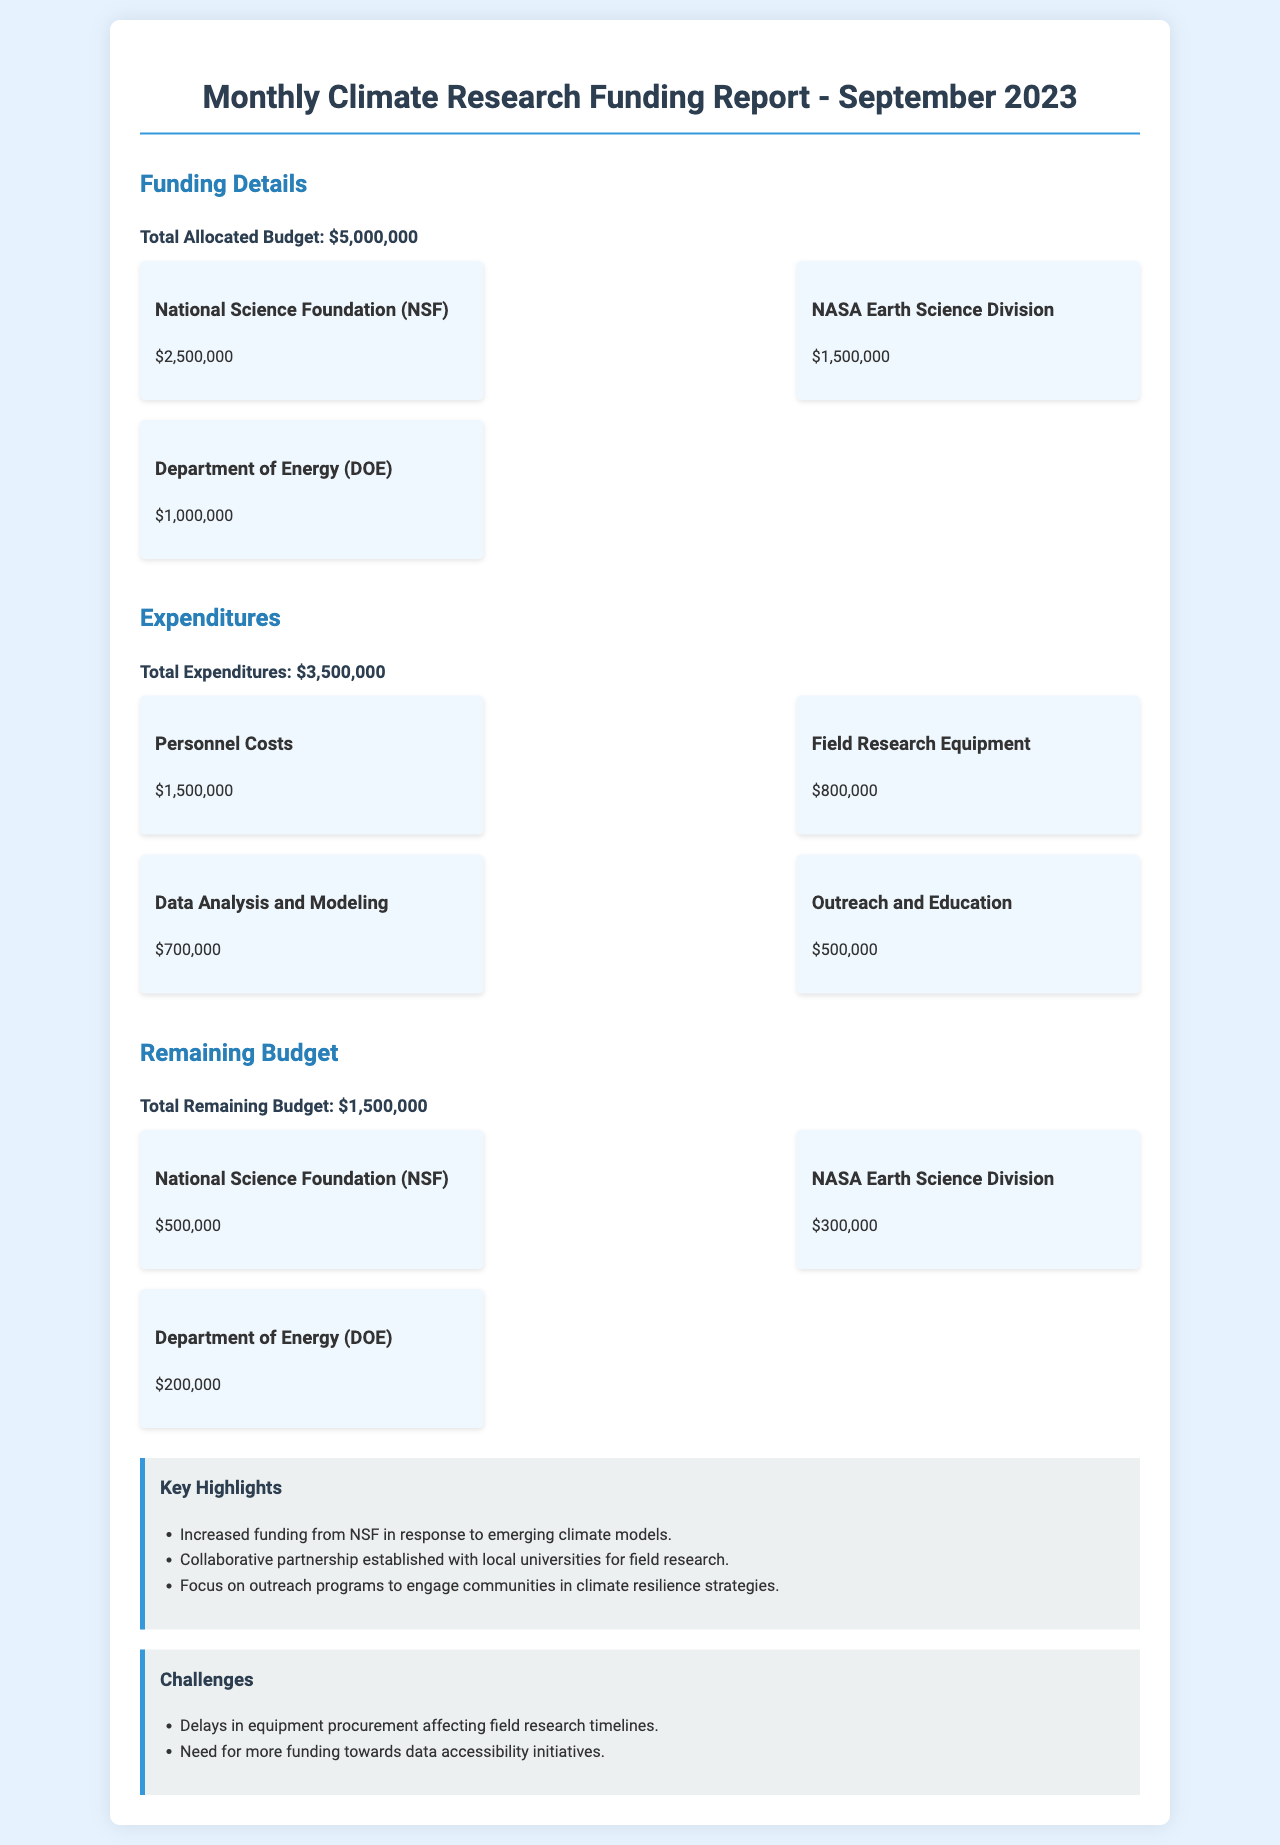what is the total allocated budget? The total allocated budget is explicitly stated in the document as $5,000,000.
Answer: $5,000,000 who provided the highest funding? The National Science Foundation (NSF) is listed as the highest funding provider with an allocation of $2,500,000.
Answer: National Science Foundation (NSF) what is the total expenditure on personnel costs? The total expenditure on personnel costs is detailed in the expenditures section and amounts to $1,500,000.
Answer: $1,500,000 how much funding is remaining from NASA Earth Science Division? The remaining funding from NASA Earth Science Division can be found in the budget section and is $300,000.
Answer: $300,000 which challenge is related to equipment? The challenge relating to equipment is mentioned in the challenges section as "Delays in equipment procurement affecting field research timelines."
Answer: Delays in equipment procurement what is the total remaining budget? The total remaining budget is clearly presented in the document as $1,500,000.
Answer: $1,500,000 what was a key highlight regarding partnerships? A key highlight states that a "Collaborative partnership established with local universities for field research" was formed.
Answer: Collaborative partnership established which expenditure received the least funding? The expenditure with the least funding is mentioned as "Outreach and Education" with an amount of $500,000.
Answer: Outreach and Education 